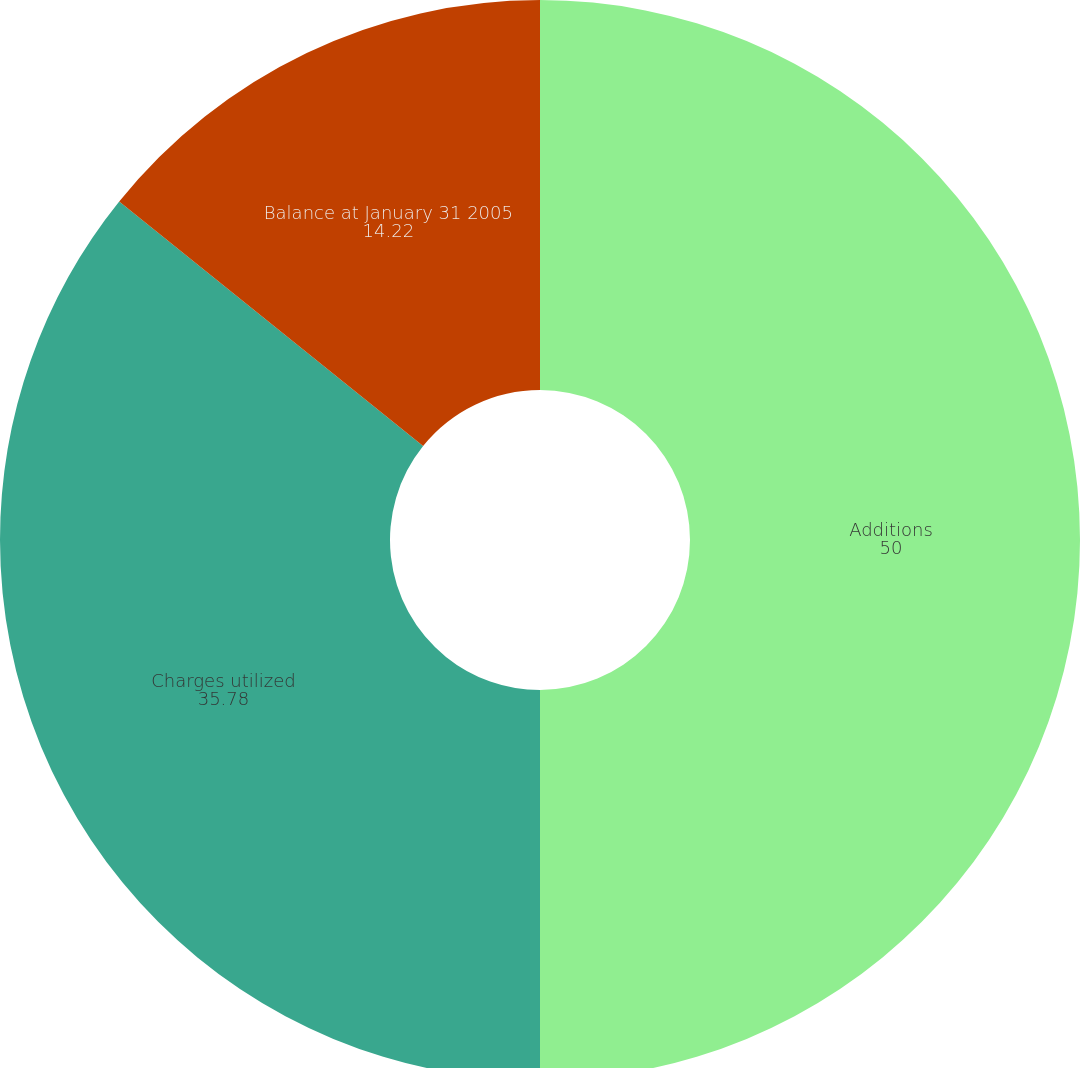<chart> <loc_0><loc_0><loc_500><loc_500><pie_chart><fcel>Additions<fcel>Charges utilized<fcel>Balance at January 31 2005<nl><fcel>50.0%<fcel>35.78%<fcel>14.22%<nl></chart> 